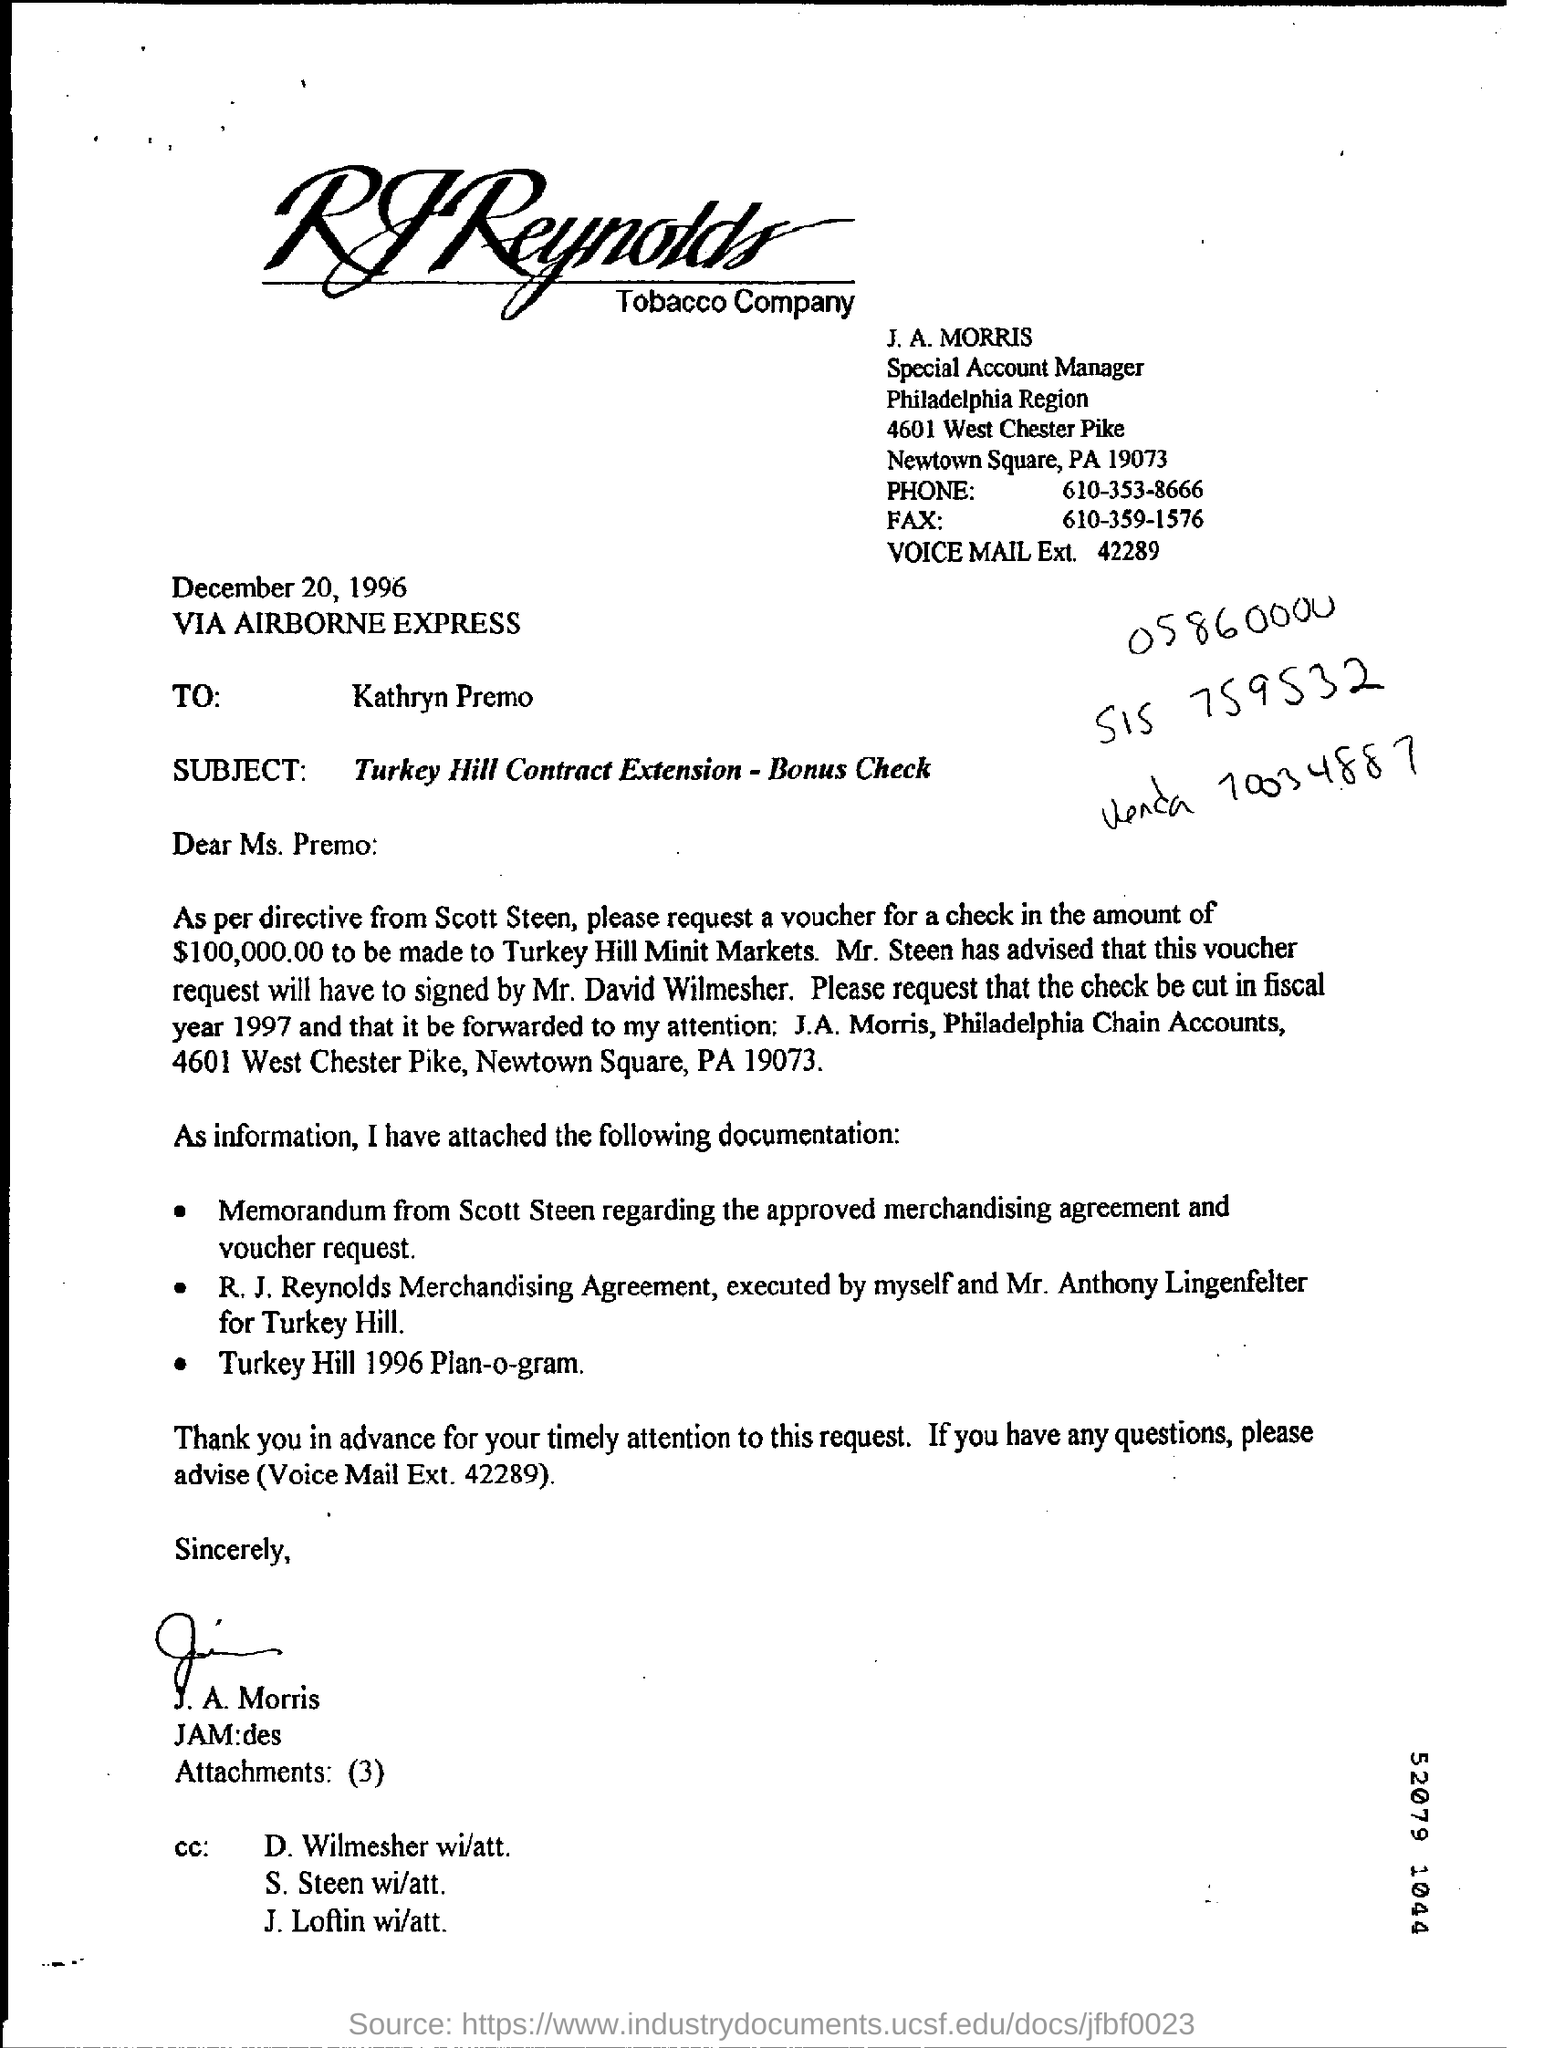What is the check amount mentioned in the document?
Offer a very short reply. 100,000.00. 